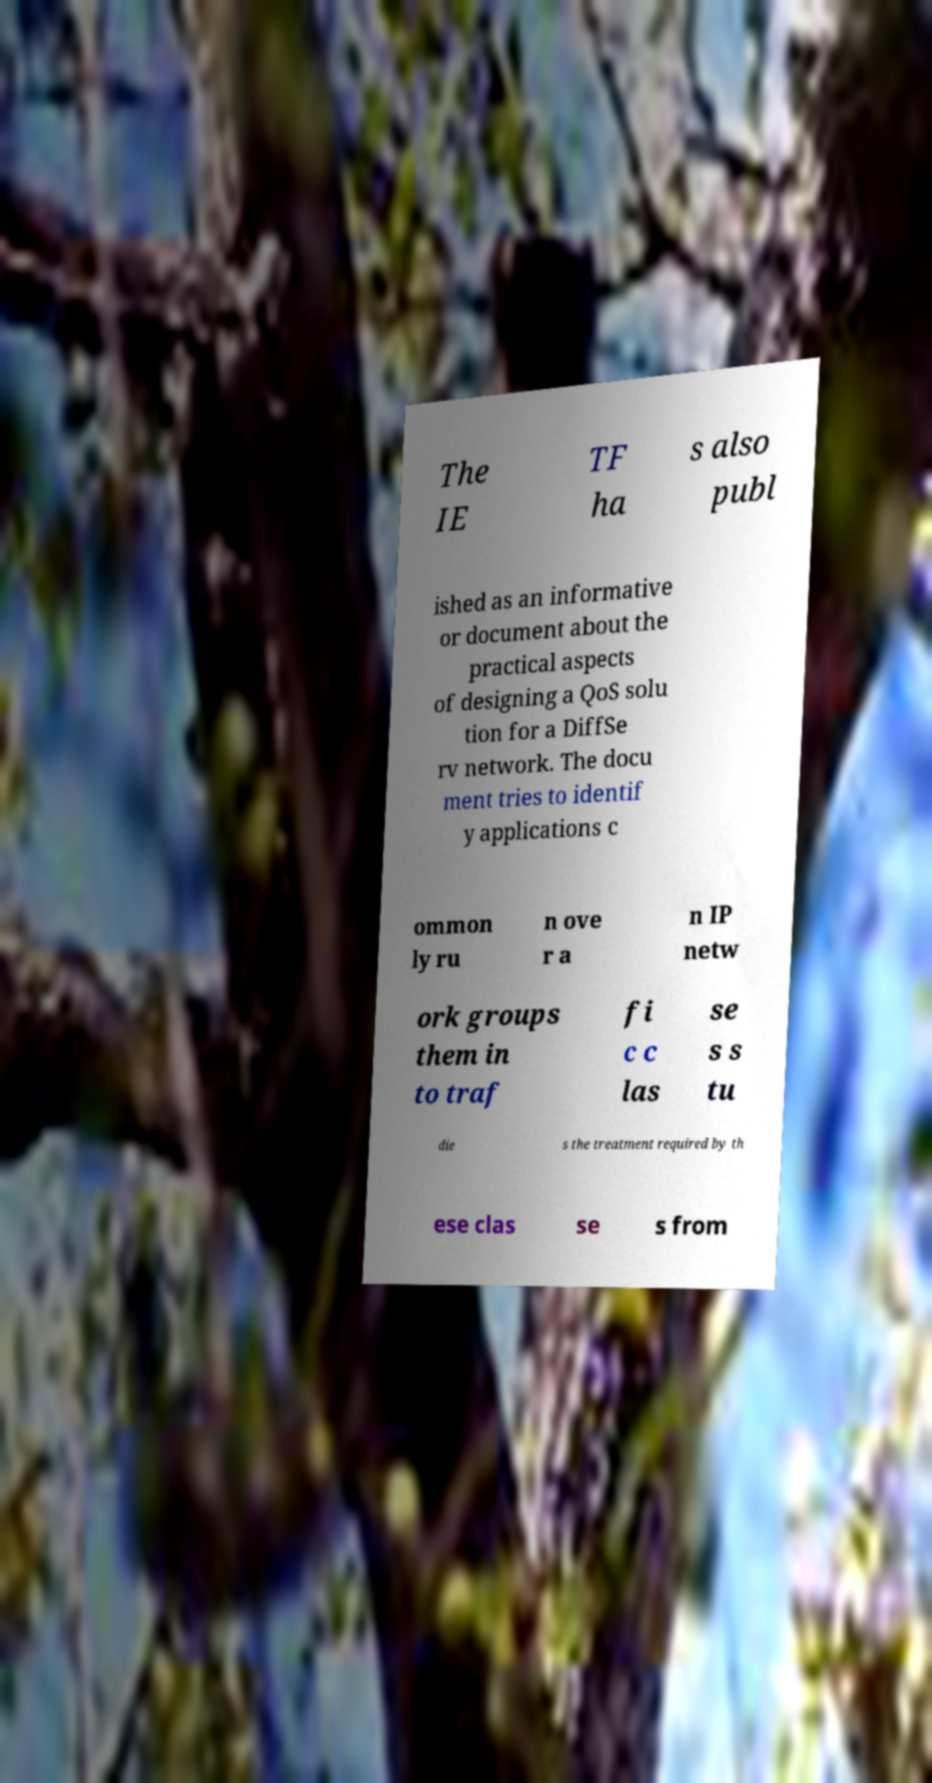There's text embedded in this image that I need extracted. Can you transcribe it verbatim? The IE TF ha s also publ ished as an informative or document about the practical aspects of designing a QoS solu tion for a DiffSe rv network. The docu ment tries to identif y applications c ommon ly ru n ove r a n IP netw ork groups them in to traf fi c c las se s s tu die s the treatment required by th ese clas se s from 